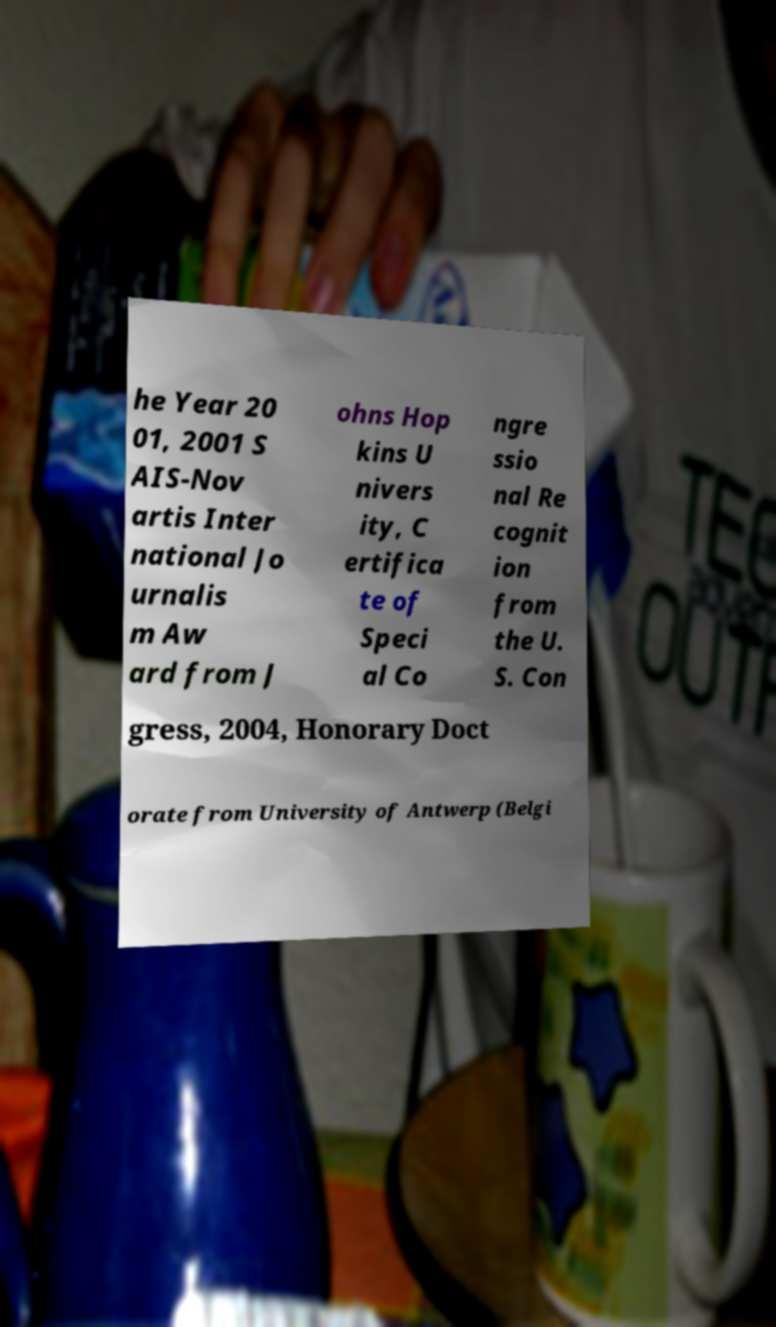What messages or text are displayed in this image? I need them in a readable, typed format. he Year 20 01, 2001 S AIS-Nov artis Inter national Jo urnalis m Aw ard from J ohns Hop kins U nivers ity, C ertifica te of Speci al Co ngre ssio nal Re cognit ion from the U. S. Con gress, 2004, Honorary Doct orate from University of Antwerp (Belgi 